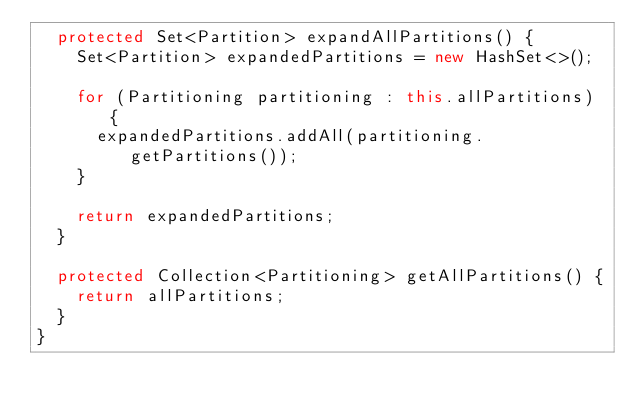Convert code to text. <code><loc_0><loc_0><loc_500><loc_500><_Java_>  protected Set<Partition> expandAllPartitions() {
    Set<Partition> expandedPartitions = new HashSet<>();

    for (Partitioning partitioning : this.allPartitions) {
      expandedPartitions.addAll(partitioning.getPartitions());
    }

    return expandedPartitions;
  }

  protected Collection<Partitioning> getAllPartitions() {
    return allPartitions;
  }
}
</code> 